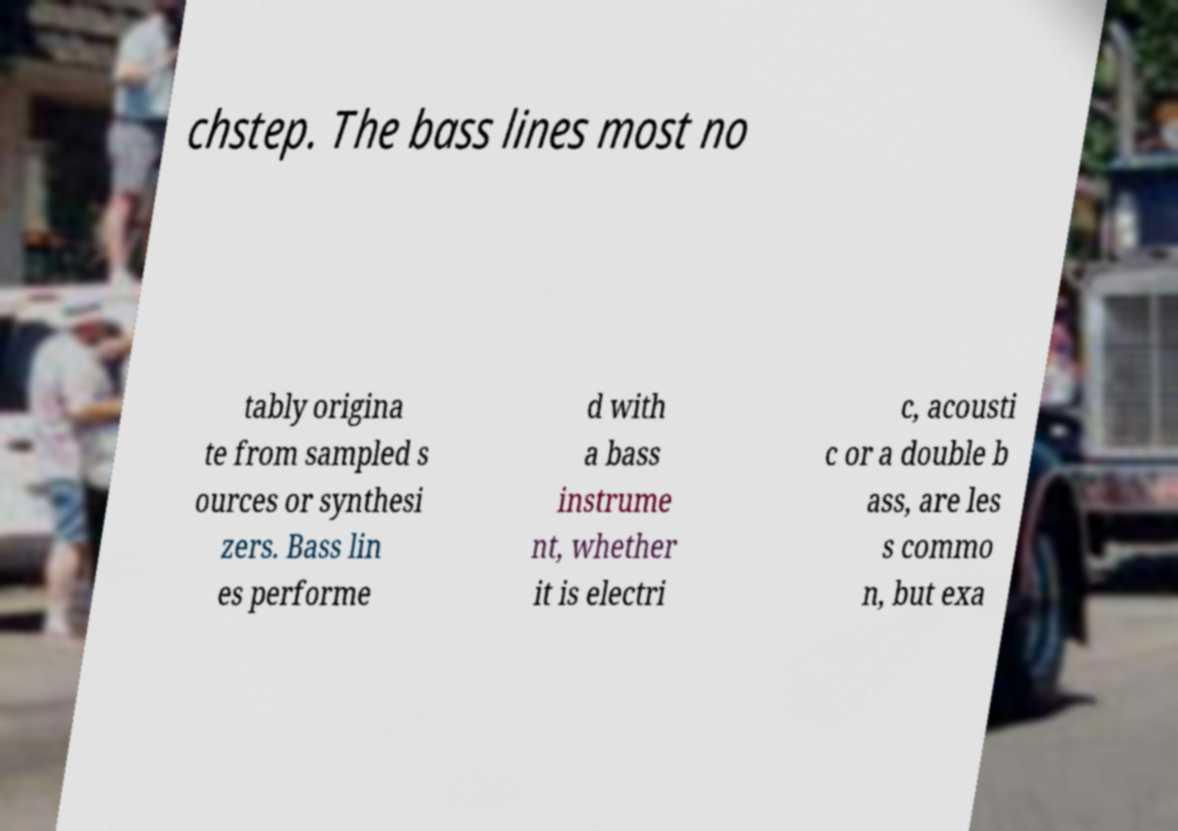Can you read and provide the text displayed in the image?This photo seems to have some interesting text. Can you extract and type it out for me? chstep. The bass lines most no tably origina te from sampled s ources or synthesi zers. Bass lin es performe d with a bass instrume nt, whether it is electri c, acousti c or a double b ass, are les s commo n, but exa 